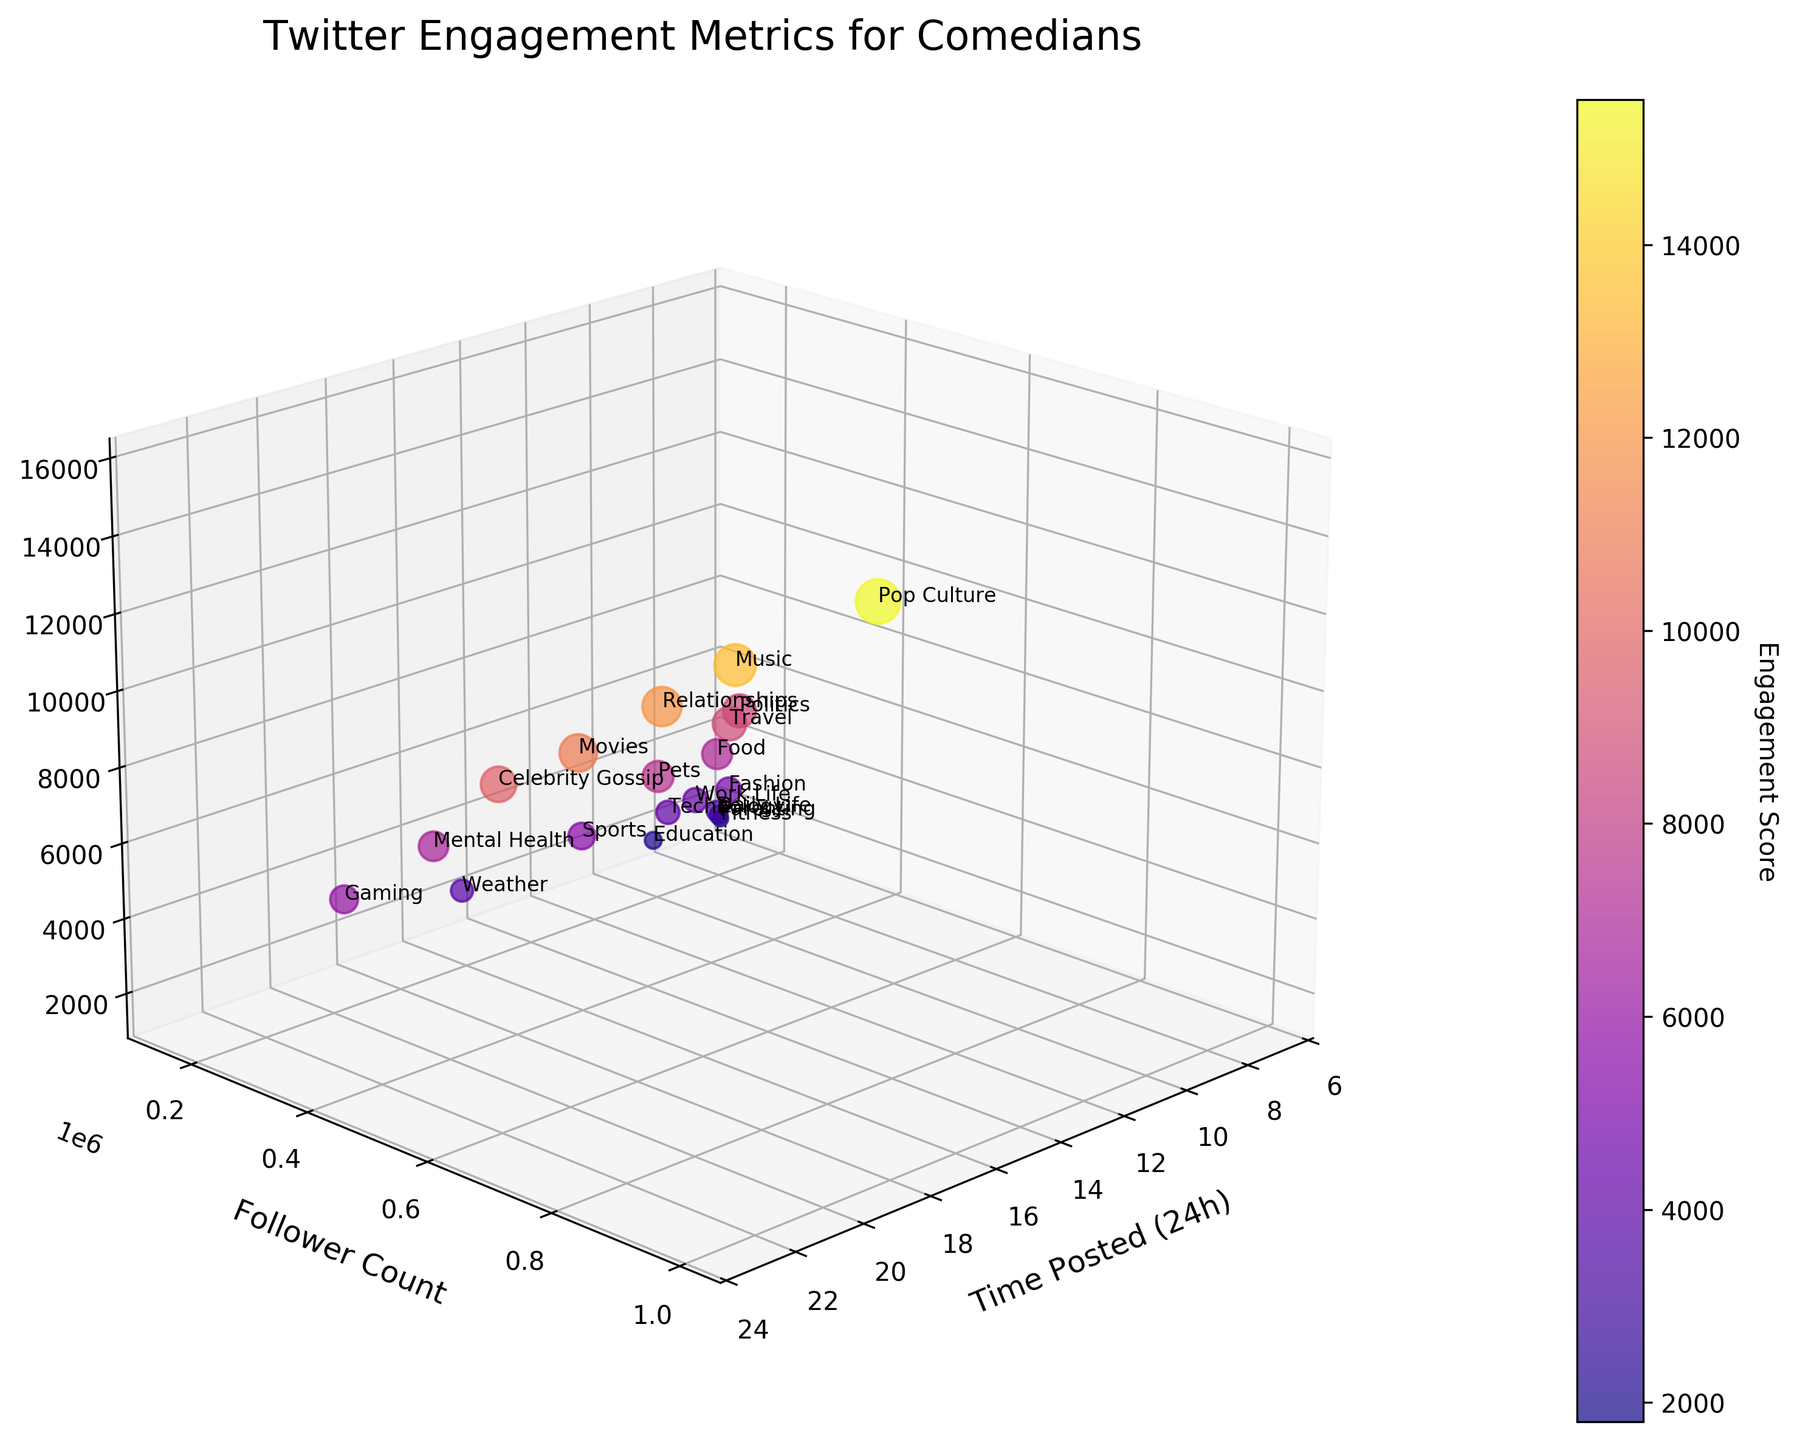what is the title of the figure? The title of the figure is typically displayed at the top of the plot in a larger and bolder font.
Answer: Twitter Engagement Metrics for Comedians What does the x-axis represent? The x-axis is labeled and typically runs horizontally along the bottom of the 3D plot, indicating what it represents.
Answer: Time Posted (24h) What's the engagement score for the topic "Pop Culture"? Look at the scatter plot to find the data point labeled "Pop Culture" and then read off its engagement score.
Answer: 15500 Which topic has the lowest follower count? Find the data point with the lowest value on the y-axis and identify its corresponding label.
Answer: Fitness What time was the joke about "Fashion" posted? Find the data point labeled "Fashion" and check its x-axis position to determine the time it was posted.
Answer: 10:30 Which topic had the highest engagement score when posted after 9:00 PM? Identify the data points posted after 21:00 (9:00 PM) by their x-axis values and compare their engagement scores to find the highest one.
Answer: Music How many topics have an engagement score above 10,000? Count the number of data points in the scatter plot with an engagement score (z-axis value) above 10,000.
Answer: 5 As follower count increases, does engagement score generally increase as well? Observe the scatter plot to see if there's a trend where points with higher y-values (follower count) also tend to have higher z-values (engagement scores).
Answer: Yes, generally Which topic had the lowest engagement score and in which time slot was it posted? Identify the data point with the lowest engagement score (z-axis value) and check its label and x-axis value for the topic and time posted.
Answer: Fitness, 07:00 